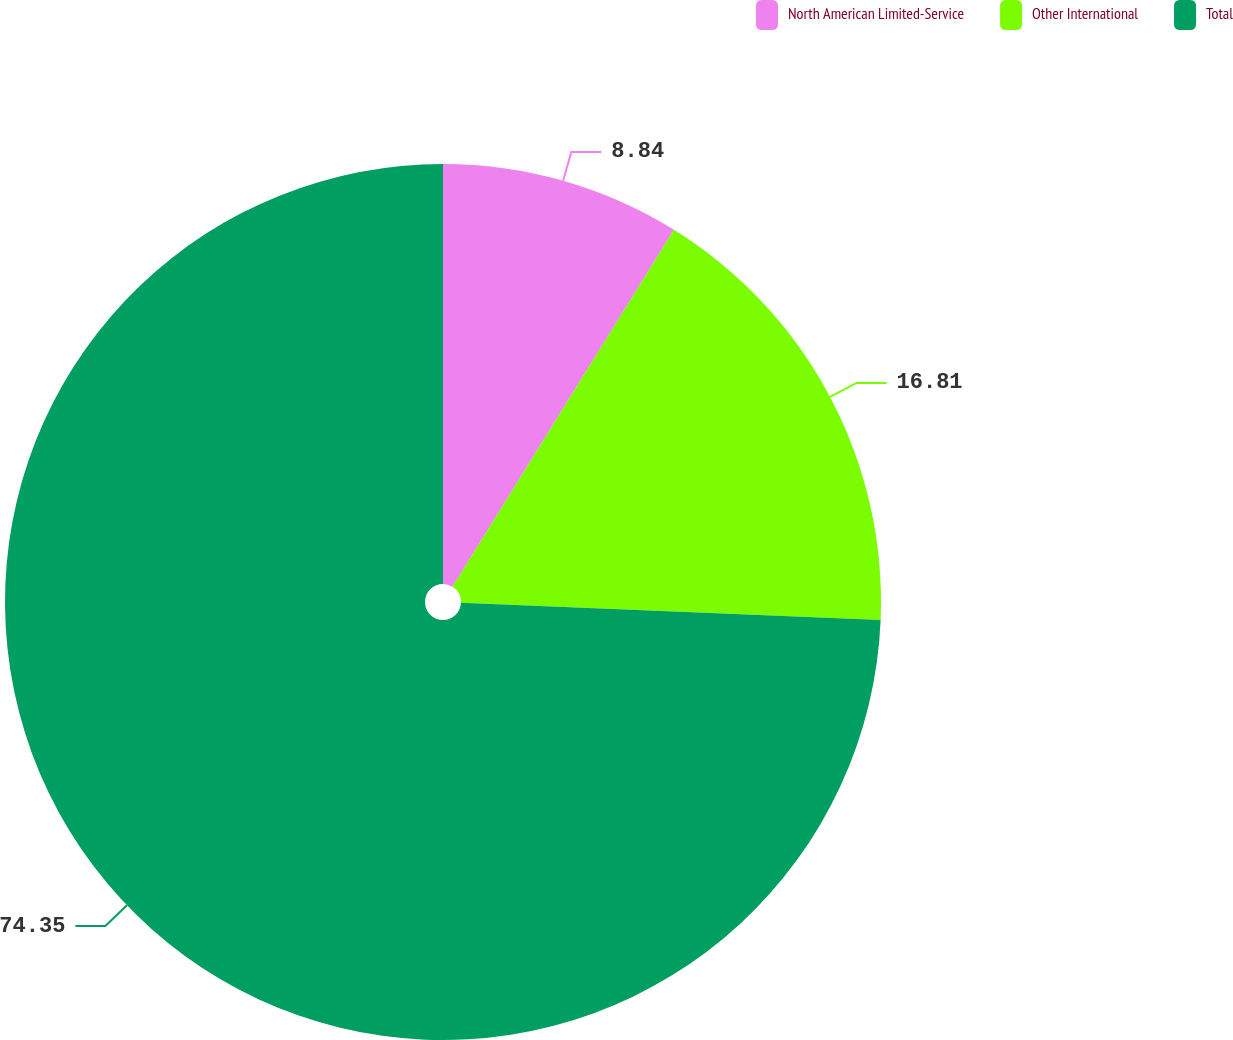<chart> <loc_0><loc_0><loc_500><loc_500><pie_chart><fcel>North American Limited-Service<fcel>Other International<fcel>Total<nl><fcel>8.84%<fcel>16.81%<fcel>74.34%<nl></chart> 